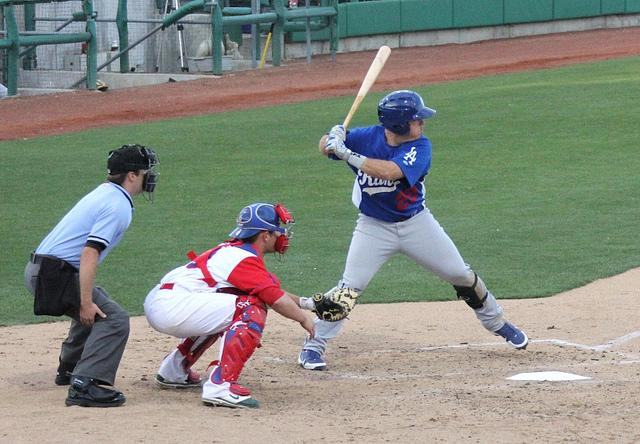What will the next thing the pitcher does?

Choices:
A) bat
B) eat lunch
C) pitch ball
D) take break pitch ball 